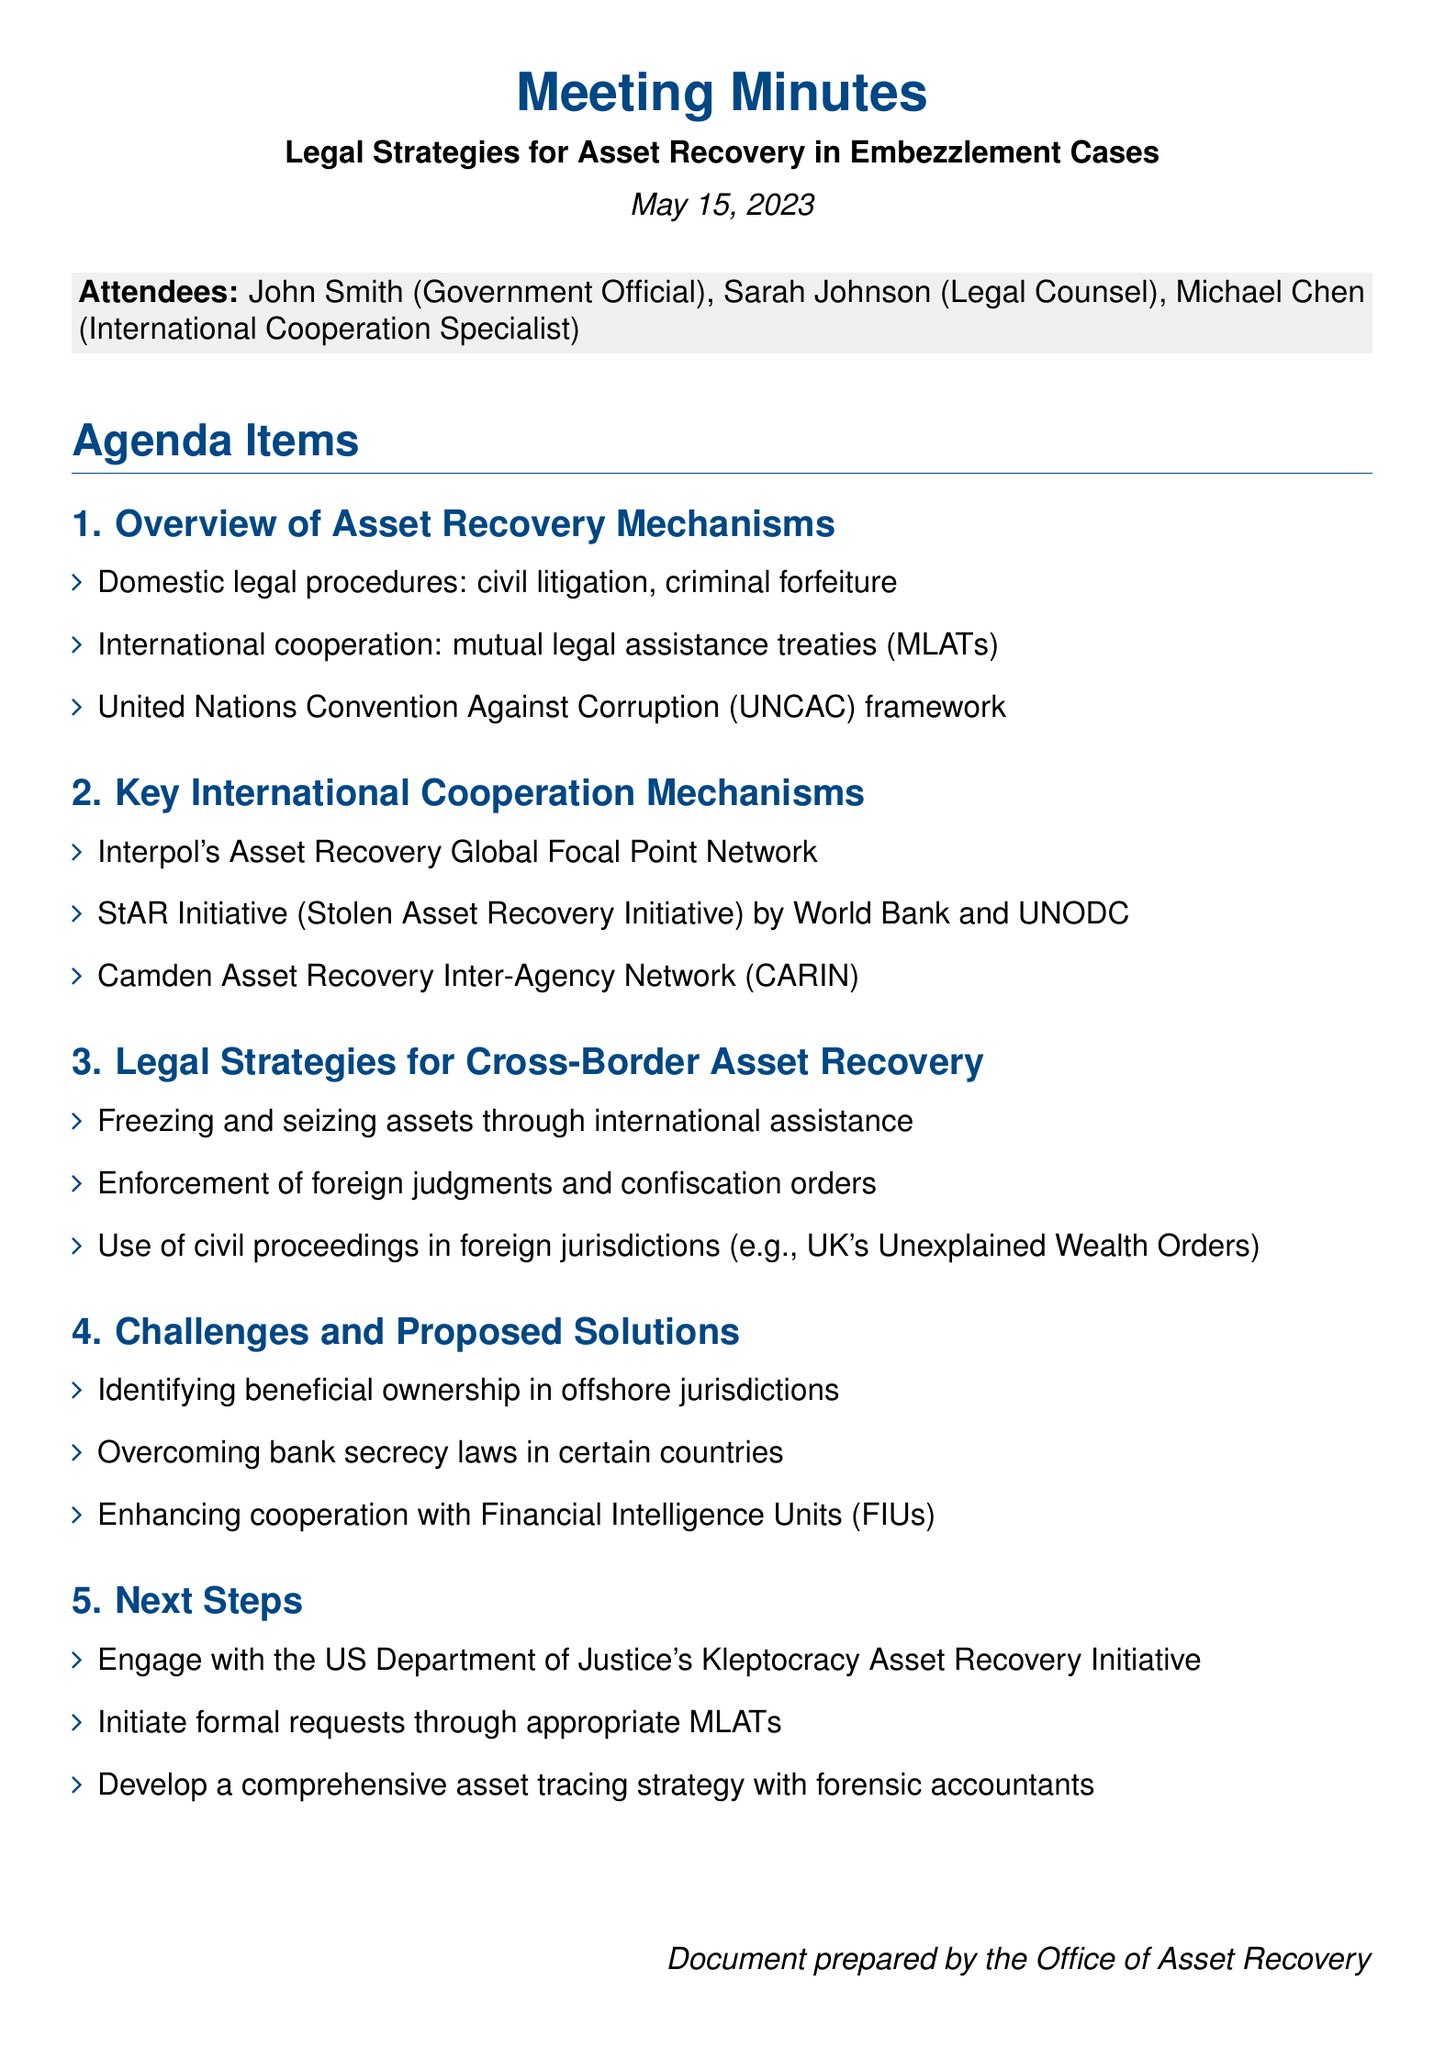What is the meeting title? The meeting title is specified at the beginning of the document, which is "Legal Strategies for Asset Recovery in Embezzlement Cases."
Answer: Legal Strategies for Asset Recovery in Embezzlement Cases Who is the International Cooperation Specialist present at the meeting? The document lists the attendees, including "Michael Chen" as the International Cooperation Specialist.
Answer: Michael Chen What framework is mentioned for international cooperation? The document points out the "United Nations Convention Against Corruption (UNCAC) framework" under the Overview of Asset Recovery Mechanisms section.
Answer: United Nations Convention Against Corruption (UNCAC) What is the StAR Initiative focused on? The StAR Initiative is defined in the Key International Cooperation Mechanisms section as the "Stolen Asset Recovery Initiative" by the World Bank and UNODC.
Answer: Stolen Asset Recovery Initiative What is one challenge identified in the meeting? The meeting notes mention challenges in identifying the "beneficial ownership in offshore jurisdictions."
Answer: Identifying beneficial ownership in offshore jurisdictions What is the proposed next step related to the US Department of Justice? The document indicates that one of the next steps is to "Engage with the US Department of Justice's Kleptocracy Asset Recovery Initiative."
Answer: Engage with the US Department of Justice's Kleptocracy Asset Recovery Initiative What date was the meeting held? The date of the meeting is provided in the document as "May 15, 2023."
Answer: May 15, 2023 What is one legal strategy mentioned for cross-border asset recovery? The document lists the ability to "freeze and seize assets through international assistance" in the Legal Strategies for Cross-Border Asset Recovery section.
Answer: Freezing and seizing assets through international assistance 